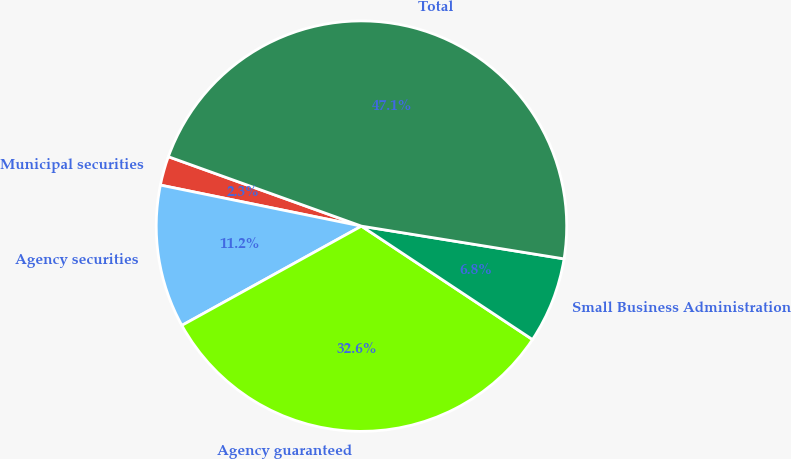Convert chart. <chart><loc_0><loc_0><loc_500><loc_500><pie_chart><fcel>Municipal securities<fcel>Agency securities<fcel>Agency guaranteed<fcel>Small Business Administration<fcel>Total<nl><fcel>2.29%<fcel>11.24%<fcel>32.64%<fcel>6.77%<fcel>47.05%<nl></chart> 